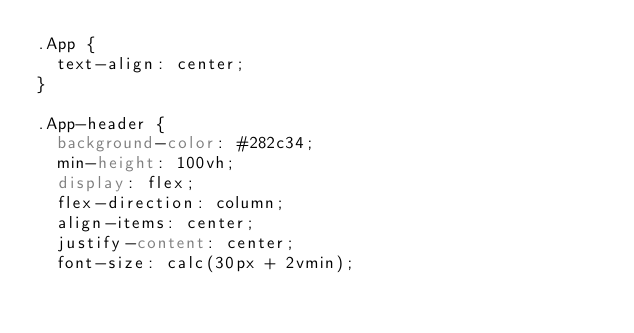<code> <loc_0><loc_0><loc_500><loc_500><_CSS_>.App {
  text-align: center;
}

.App-header {
  background-color: #282c34;
  min-height: 100vh;
  display: flex;
  flex-direction: column;
  align-items: center;
  justify-content: center;
  font-size: calc(30px + 2vmin);</code> 